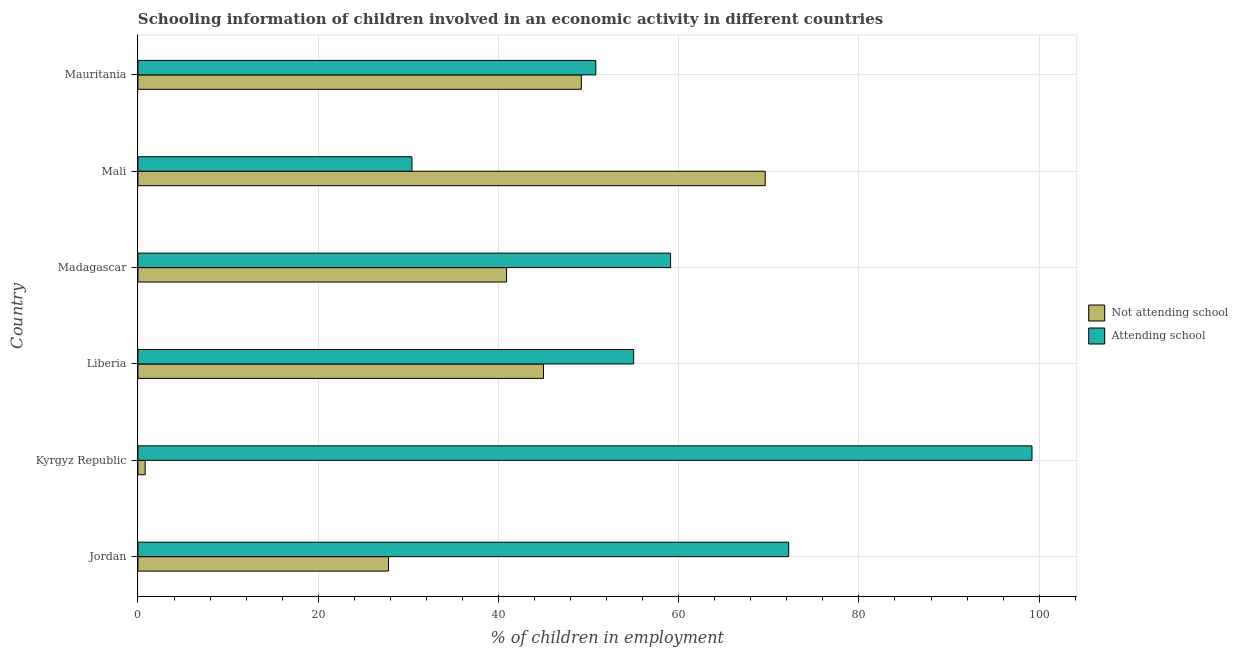How many groups of bars are there?
Ensure brevity in your answer.  6. How many bars are there on the 3rd tick from the top?
Your answer should be compact. 2. What is the label of the 5th group of bars from the top?
Provide a short and direct response. Kyrgyz Republic. In how many cases, is the number of bars for a given country not equal to the number of legend labels?
Ensure brevity in your answer.  0. What is the percentage of employed children who are not attending school in Madagascar?
Your answer should be very brief. 40.9. Across all countries, what is the maximum percentage of employed children who are attending school?
Provide a short and direct response. 99.2. Across all countries, what is the minimum percentage of employed children who are attending school?
Offer a very short reply. 30.4. In which country was the percentage of employed children who are not attending school maximum?
Offer a very short reply. Mali. In which country was the percentage of employed children who are not attending school minimum?
Keep it short and to the point. Kyrgyz Republic. What is the total percentage of employed children who are attending school in the graph?
Your response must be concise. 366.7. What is the difference between the percentage of employed children who are attending school in Mali and that in Mauritania?
Your answer should be very brief. -20.4. What is the difference between the percentage of employed children who are attending school in Mali and the percentage of employed children who are not attending school in Mauritania?
Offer a terse response. -18.8. What is the average percentage of employed children who are attending school per country?
Give a very brief answer. 61.12. In how many countries, is the percentage of employed children who are attending school greater than 16 %?
Give a very brief answer. 6. What is the ratio of the percentage of employed children who are not attending school in Jordan to that in Madagascar?
Provide a short and direct response. 0.68. Is the percentage of employed children who are not attending school in Jordan less than that in Liberia?
Offer a very short reply. Yes. What is the difference between the highest and the lowest percentage of employed children who are not attending school?
Offer a very short reply. 68.8. In how many countries, is the percentage of employed children who are attending school greater than the average percentage of employed children who are attending school taken over all countries?
Your answer should be compact. 2. Is the sum of the percentage of employed children who are not attending school in Jordan and Madagascar greater than the maximum percentage of employed children who are attending school across all countries?
Provide a succinct answer. No. What does the 2nd bar from the top in Liberia represents?
Offer a very short reply. Not attending school. What does the 1st bar from the bottom in Kyrgyz Republic represents?
Ensure brevity in your answer.  Not attending school. How many bars are there?
Make the answer very short. 12. How many countries are there in the graph?
Your answer should be compact. 6. What is the difference between two consecutive major ticks on the X-axis?
Give a very brief answer. 20. Are the values on the major ticks of X-axis written in scientific E-notation?
Your answer should be very brief. No. Does the graph contain grids?
Your answer should be compact. Yes. Where does the legend appear in the graph?
Give a very brief answer. Center right. What is the title of the graph?
Ensure brevity in your answer.  Schooling information of children involved in an economic activity in different countries. What is the label or title of the X-axis?
Offer a terse response. % of children in employment. What is the label or title of the Y-axis?
Provide a succinct answer. Country. What is the % of children in employment of Not attending school in Jordan?
Your answer should be compact. 27.8. What is the % of children in employment in Attending school in Jordan?
Your answer should be compact. 72.2. What is the % of children in employment in Attending school in Kyrgyz Republic?
Your response must be concise. 99.2. What is the % of children in employment of Not attending school in Liberia?
Make the answer very short. 45. What is the % of children in employment of Not attending school in Madagascar?
Your response must be concise. 40.9. What is the % of children in employment of Attending school in Madagascar?
Ensure brevity in your answer.  59.1. What is the % of children in employment in Not attending school in Mali?
Ensure brevity in your answer.  69.6. What is the % of children in employment of Attending school in Mali?
Make the answer very short. 30.4. What is the % of children in employment of Not attending school in Mauritania?
Make the answer very short. 49.2. What is the % of children in employment of Attending school in Mauritania?
Provide a short and direct response. 50.8. Across all countries, what is the maximum % of children in employment of Not attending school?
Offer a very short reply. 69.6. Across all countries, what is the maximum % of children in employment of Attending school?
Provide a short and direct response. 99.2. Across all countries, what is the minimum % of children in employment of Not attending school?
Your response must be concise. 0.8. Across all countries, what is the minimum % of children in employment in Attending school?
Make the answer very short. 30.4. What is the total % of children in employment in Not attending school in the graph?
Provide a short and direct response. 233.3. What is the total % of children in employment of Attending school in the graph?
Offer a terse response. 366.7. What is the difference between the % of children in employment in Not attending school in Jordan and that in Kyrgyz Republic?
Offer a very short reply. 27. What is the difference between the % of children in employment in Not attending school in Jordan and that in Liberia?
Ensure brevity in your answer.  -17.2. What is the difference between the % of children in employment in Attending school in Jordan and that in Liberia?
Provide a short and direct response. 17.2. What is the difference between the % of children in employment in Not attending school in Jordan and that in Madagascar?
Keep it short and to the point. -13.1. What is the difference between the % of children in employment in Attending school in Jordan and that in Madagascar?
Your answer should be very brief. 13.1. What is the difference between the % of children in employment of Not attending school in Jordan and that in Mali?
Your answer should be compact. -41.8. What is the difference between the % of children in employment in Attending school in Jordan and that in Mali?
Your answer should be compact. 41.8. What is the difference between the % of children in employment in Not attending school in Jordan and that in Mauritania?
Your response must be concise. -21.4. What is the difference between the % of children in employment of Attending school in Jordan and that in Mauritania?
Make the answer very short. 21.4. What is the difference between the % of children in employment of Not attending school in Kyrgyz Republic and that in Liberia?
Provide a short and direct response. -44.2. What is the difference between the % of children in employment in Attending school in Kyrgyz Republic and that in Liberia?
Give a very brief answer. 44.2. What is the difference between the % of children in employment in Not attending school in Kyrgyz Republic and that in Madagascar?
Your answer should be very brief. -40.1. What is the difference between the % of children in employment in Attending school in Kyrgyz Republic and that in Madagascar?
Provide a succinct answer. 40.1. What is the difference between the % of children in employment of Not attending school in Kyrgyz Republic and that in Mali?
Keep it short and to the point. -68.8. What is the difference between the % of children in employment of Attending school in Kyrgyz Republic and that in Mali?
Give a very brief answer. 68.8. What is the difference between the % of children in employment in Not attending school in Kyrgyz Republic and that in Mauritania?
Offer a very short reply. -48.4. What is the difference between the % of children in employment in Attending school in Kyrgyz Republic and that in Mauritania?
Offer a terse response. 48.4. What is the difference between the % of children in employment in Not attending school in Liberia and that in Madagascar?
Make the answer very short. 4.1. What is the difference between the % of children in employment of Not attending school in Liberia and that in Mali?
Your answer should be very brief. -24.6. What is the difference between the % of children in employment of Attending school in Liberia and that in Mali?
Ensure brevity in your answer.  24.6. What is the difference between the % of children in employment in Not attending school in Liberia and that in Mauritania?
Offer a terse response. -4.2. What is the difference between the % of children in employment of Attending school in Liberia and that in Mauritania?
Your response must be concise. 4.2. What is the difference between the % of children in employment of Not attending school in Madagascar and that in Mali?
Your answer should be compact. -28.7. What is the difference between the % of children in employment of Attending school in Madagascar and that in Mali?
Make the answer very short. 28.7. What is the difference between the % of children in employment in Not attending school in Madagascar and that in Mauritania?
Keep it short and to the point. -8.3. What is the difference between the % of children in employment of Attending school in Madagascar and that in Mauritania?
Provide a short and direct response. 8.3. What is the difference between the % of children in employment of Not attending school in Mali and that in Mauritania?
Your response must be concise. 20.4. What is the difference between the % of children in employment of Attending school in Mali and that in Mauritania?
Provide a succinct answer. -20.4. What is the difference between the % of children in employment of Not attending school in Jordan and the % of children in employment of Attending school in Kyrgyz Republic?
Your response must be concise. -71.4. What is the difference between the % of children in employment of Not attending school in Jordan and the % of children in employment of Attending school in Liberia?
Provide a short and direct response. -27.2. What is the difference between the % of children in employment in Not attending school in Jordan and the % of children in employment in Attending school in Madagascar?
Your response must be concise. -31.3. What is the difference between the % of children in employment of Not attending school in Kyrgyz Republic and the % of children in employment of Attending school in Liberia?
Keep it short and to the point. -54.2. What is the difference between the % of children in employment of Not attending school in Kyrgyz Republic and the % of children in employment of Attending school in Madagascar?
Offer a terse response. -58.3. What is the difference between the % of children in employment in Not attending school in Kyrgyz Republic and the % of children in employment in Attending school in Mali?
Make the answer very short. -29.6. What is the difference between the % of children in employment in Not attending school in Liberia and the % of children in employment in Attending school in Madagascar?
Your answer should be compact. -14.1. What is the difference between the % of children in employment of Not attending school in Liberia and the % of children in employment of Attending school in Mauritania?
Ensure brevity in your answer.  -5.8. What is the difference between the % of children in employment in Not attending school in Mali and the % of children in employment in Attending school in Mauritania?
Keep it short and to the point. 18.8. What is the average % of children in employment of Not attending school per country?
Provide a short and direct response. 38.88. What is the average % of children in employment of Attending school per country?
Your answer should be compact. 61.12. What is the difference between the % of children in employment in Not attending school and % of children in employment in Attending school in Jordan?
Give a very brief answer. -44.4. What is the difference between the % of children in employment in Not attending school and % of children in employment in Attending school in Kyrgyz Republic?
Give a very brief answer. -98.4. What is the difference between the % of children in employment in Not attending school and % of children in employment in Attending school in Madagascar?
Your answer should be very brief. -18.2. What is the difference between the % of children in employment in Not attending school and % of children in employment in Attending school in Mali?
Keep it short and to the point. 39.2. What is the difference between the % of children in employment in Not attending school and % of children in employment in Attending school in Mauritania?
Offer a terse response. -1.6. What is the ratio of the % of children in employment of Not attending school in Jordan to that in Kyrgyz Republic?
Provide a succinct answer. 34.75. What is the ratio of the % of children in employment in Attending school in Jordan to that in Kyrgyz Republic?
Provide a short and direct response. 0.73. What is the ratio of the % of children in employment of Not attending school in Jordan to that in Liberia?
Ensure brevity in your answer.  0.62. What is the ratio of the % of children in employment in Attending school in Jordan to that in Liberia?
Offer a very short reply. 1.31. What is the ratio of the % of children in employment of Not attending school in Jordan to that in Madagascar?
Ensure brevity in your answer.  0.68. What is the ratio of the % of children in employment of Attending school in Jordan to that in Madagascar?
Your answer should be very brief. 1.22. What is the ratio of the % of children in employment in Not attending school in Jordan to that in Mali?
Offer a very short reply. 0.4. What is the ratio of the % of children in employment of Attending school in Jordan to that in Mali?
Ensure brevity in your answer.  2.38. What is the ratio of the % of children in employment of Not attending school in Jordan to that in Mauritania?
Your response must be concise. 0.56. What is the ratio of the % of children in employment of Attending school in Jordan to that in Mauritania?
Your answer should be compact. 1.42. What is the ratio of the % of children in employment in Not attending school in Kyrgyz Republic to that in Liberia?
Offer a terse response. 0.02. What is the ratio of the % of children in employment of Attending school in Kyrgyz Republic to that in Liberia?
Your response must be concise. 1.8. What is the ratio of the % of children in employment in Not attending school in Kyrgyz Republic to that in Madagascar?
Your response must be concise. 0.02. What is the ratio of the % of children in employment of Attending school in Kyrgyz Republic to that in Madagascar?
Offer a terse response. 1.68. What is the ratio of the % of children in employment of Not attending school in Kyrgyz Republic to that in Mali?
Your response must be concise. 0.01. What is the ratio of the % of children in employment in Attending school in Kyrgyz Republic to that in Mali?
Keep it short and to the point. 3.26. What is the ratio of the % of children in employment of Not attending school in Kyrgyz Republic to that in Mauritania?
Make the answer very short. 0.02. What is the ratio of the % of children in employment of Attending school in Kyrgyz Republic to that in Mauritania?
Your answer should be compact. 1.95. What is the ratio of the % of children in employment in Not attending school in Liberia to that in Madagascar?
Your response must be concise. 1.1. What is the ratio of the % of children in employment of Attending school in Liberia to that in Madagascar?
Ensure brevity in your answer.  0.93. What is the ratio of the % of children in employment in Not attending school in Liberia to that in Mali?
Your response must be concise. 0.65. What is the ratio of the % of children in employment in Attending school in Liberia to that in Mali?
Ensure brevity in your answer.  1.81. What is the ratio of the % of children in employment of Not attending school in Liberia to that in Mauritania?
Your answer should be very brief. 0.91. What is the ratio of the % of children in employment of Attending school in Liberia to that in Mauritania?
Give a very brief answer. 1.08. What is the ratio of the % of children in employment in Not attending school in Madagascar to that in Mali?
Your response must be concise. 0.59. What is the ratio of the % of children in employment of Attending school in Madagascar to that in Mali?
Offer a very short reply. 1.94. What is the ratio of the % of children in employment of Not attending school in Madagascar to that in Mauritania?
Ensure brevity in your answer.  0.83. What is the ratio of the % of children in employment of Attending school in Madagascar to that in Mauritania?
Your response must be concise. 1.16. What is the ratio of the % of children in employment in Not attending school in Mali to that in Mauritania?
Your response must be concise. 1.41. What is the ratio of the % of children in employment in Attending school in Mali to that in Mauritania?
Keep it short and to the point. 0.6. What is the difference between the highest and the second highest % of children in employment of Not attending school?
Keep it short and to the point. 20.4. What is the difference between the highest and the lowest % of children in employment in Not attending school?
Ensure brevity in your answer.  68.8. What is the difference between the highest and the lowest % of children in employment of Attending school?
Give a very brief answer. 68.8. 